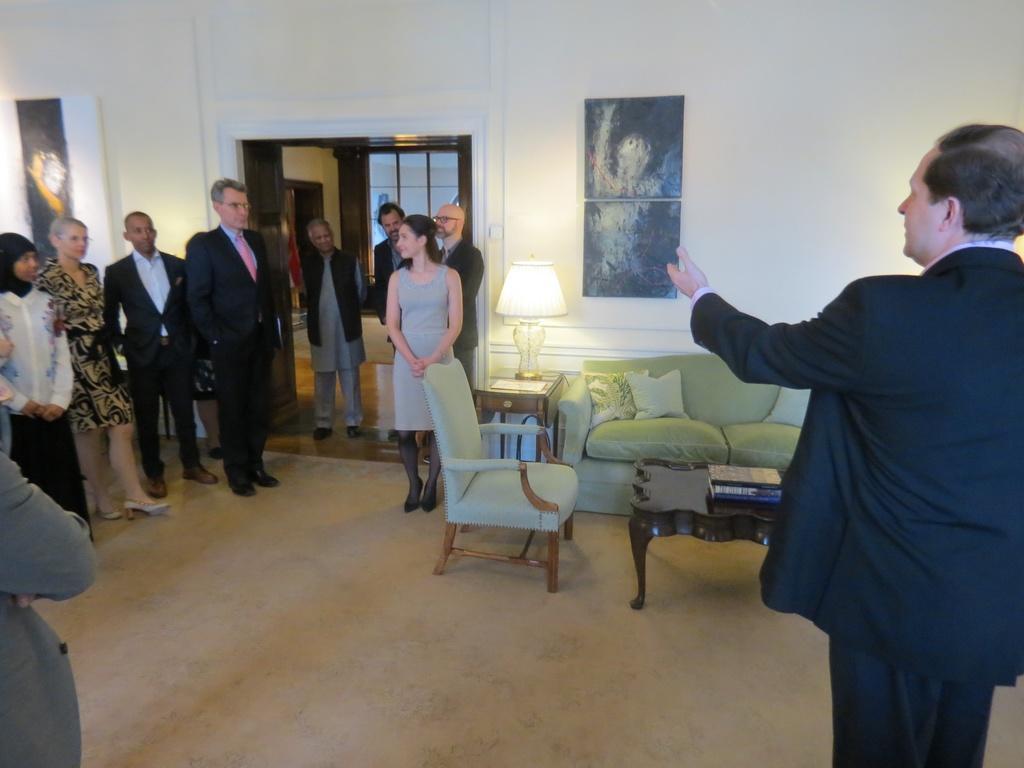How would you summarize this image in a sentence or two? There are group of people standing here. There are men and women in this group. And one guy in the right side is calling them. We can observe sofas table lamp and award in the background. p 